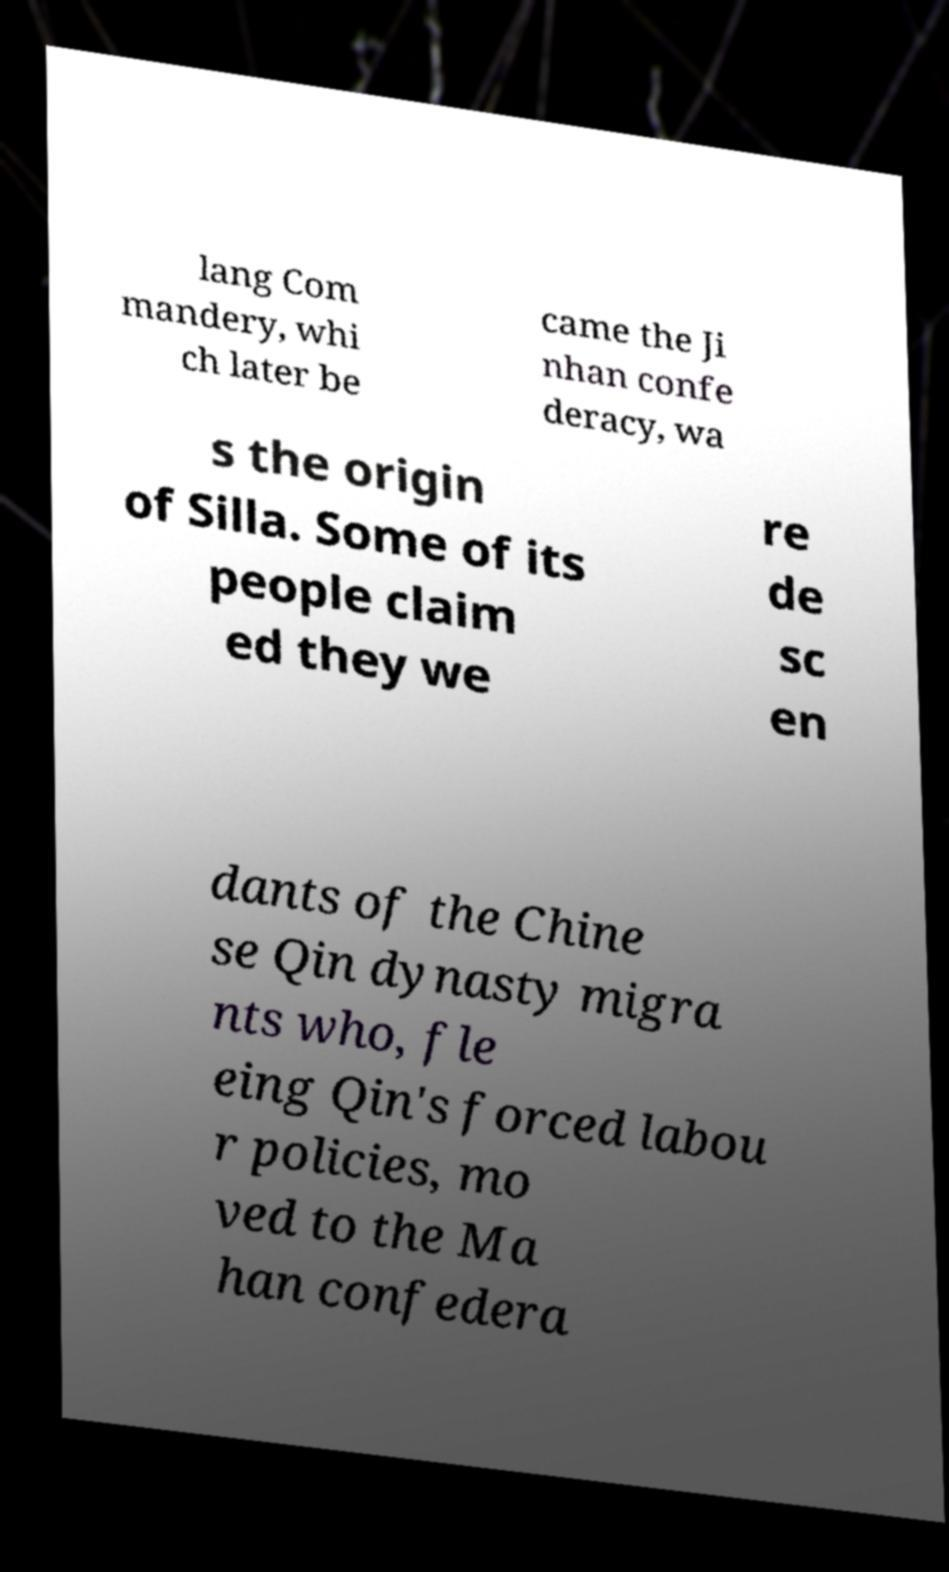Can you accurately transcribe the text from the provided image for me? lang Com mandery, whi ch later be came the Ji nhan confe deracy, wa s the origin of Silla. Some of its people claim ed they we re de sc en dants of the Chine se Qin dynasty migra nts who, fle eing Qin's forced labou r policies, mo ved to the Ma han confedera 